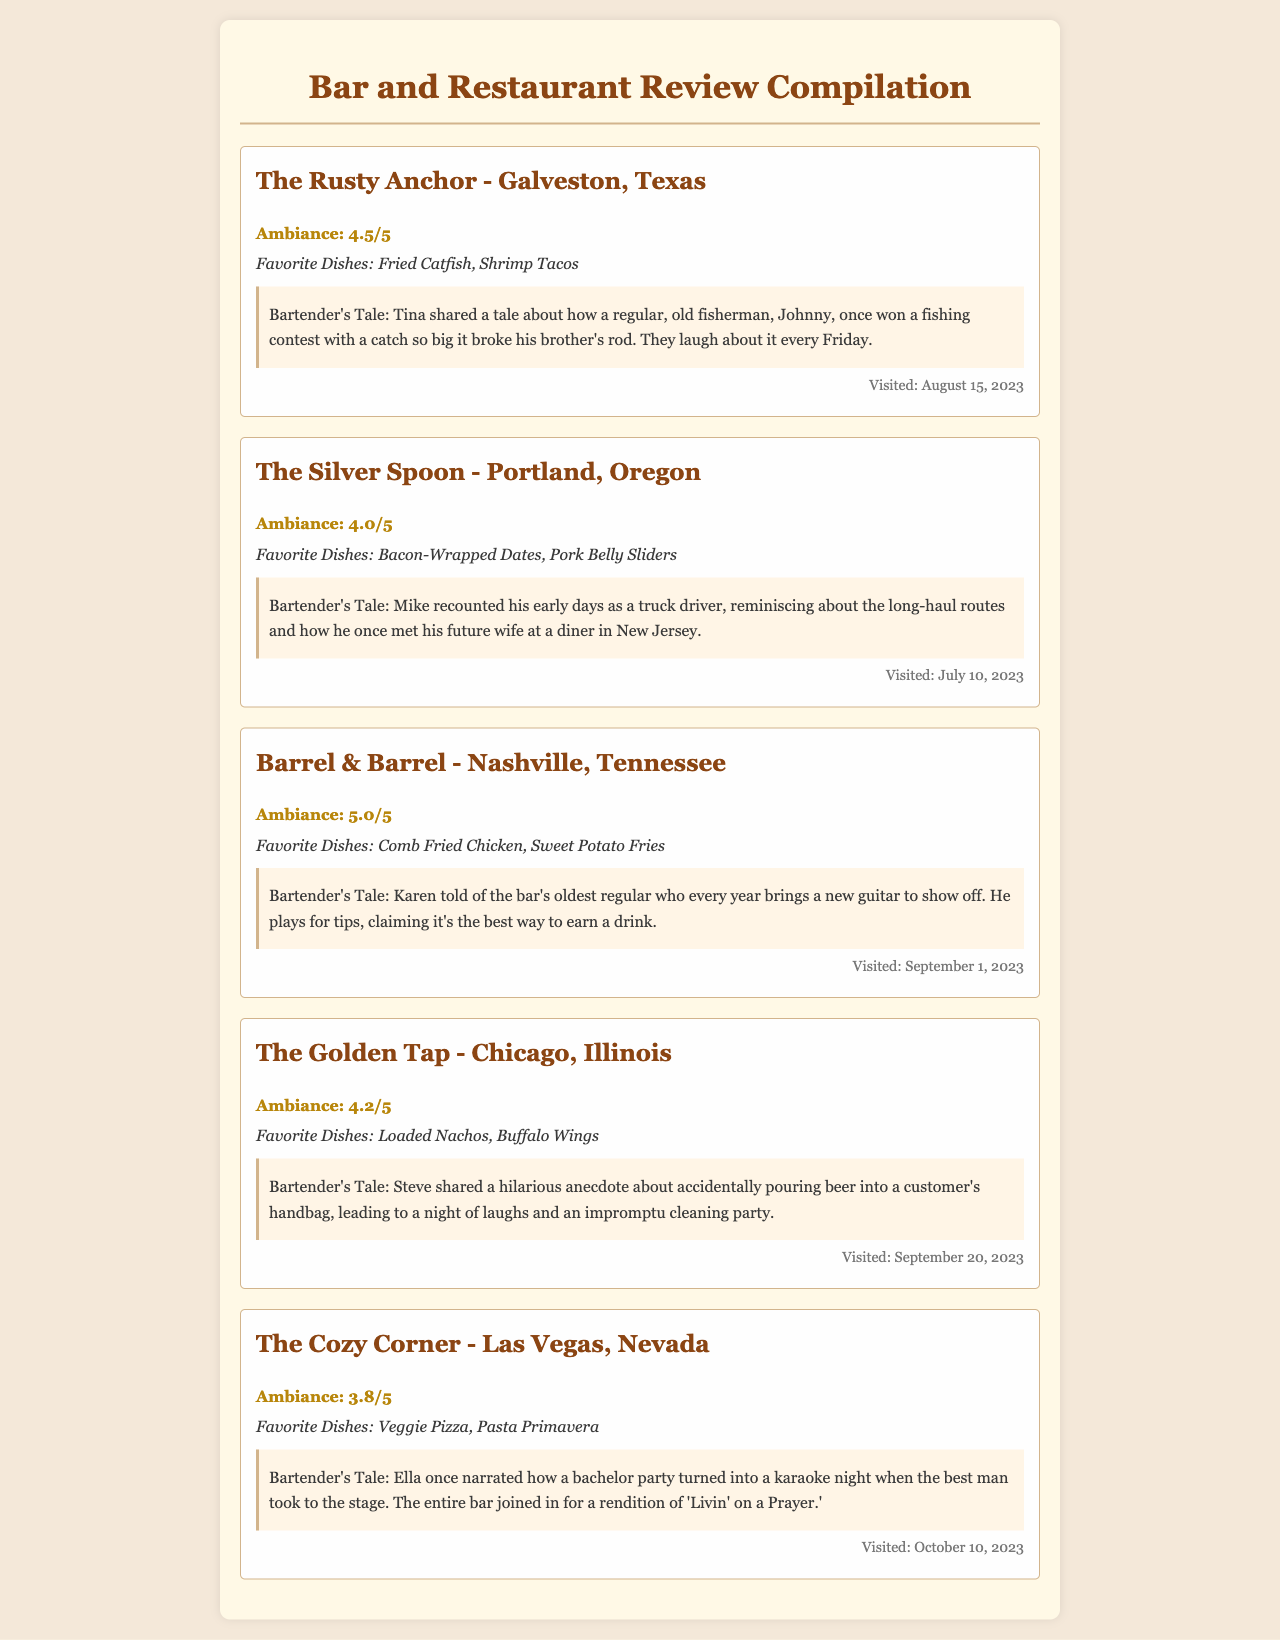What is the ambiance rating of The Rusty Anchor? The ambiance rating is a specific number given in the review for The Rusty Anchor.
Answer: 4.5/5 What was the favorite dish at The Silver Spoon? The favorite dish is located in the specific section describing the dining experience at The Silver Spoon.
Answer: Bacon-Wrapped Dates Who shared a tale about a fishing contest at The Rusty Anchor? The story section mentions the bartender who shared the tale.
Answer: Tina What is the date of the visit to Barrel & Barrel? The visiting date is provided in the review for Barrel & Barrel.
Answer: September 1, 2023 What was the ambiance rating of The Cozy Corner? The ambiance rating can be found in the review for The Cozy Corner and is a precise number.
Answer: 3.8/5 Which dish was favored at The Golden Tap? The favorite dish is specifically mentioned in the review for The Golden Tap.
Answer: Loaded Nachos How many different bars are reviewed in this document? The total number of reviews counts the distinct bars listed in the document.
Answer: 5 What unique event happened at The Cozy Corner during a bachelor party? This event is described in the story section for The Cozy Corner, indicating a memorable experience.
Answer: Karaoke night What role did Ella play in the story shared at The Cozy Corner? Ella's role is provided in the context of the bartender's tale in her review.
Answer: Bartender 